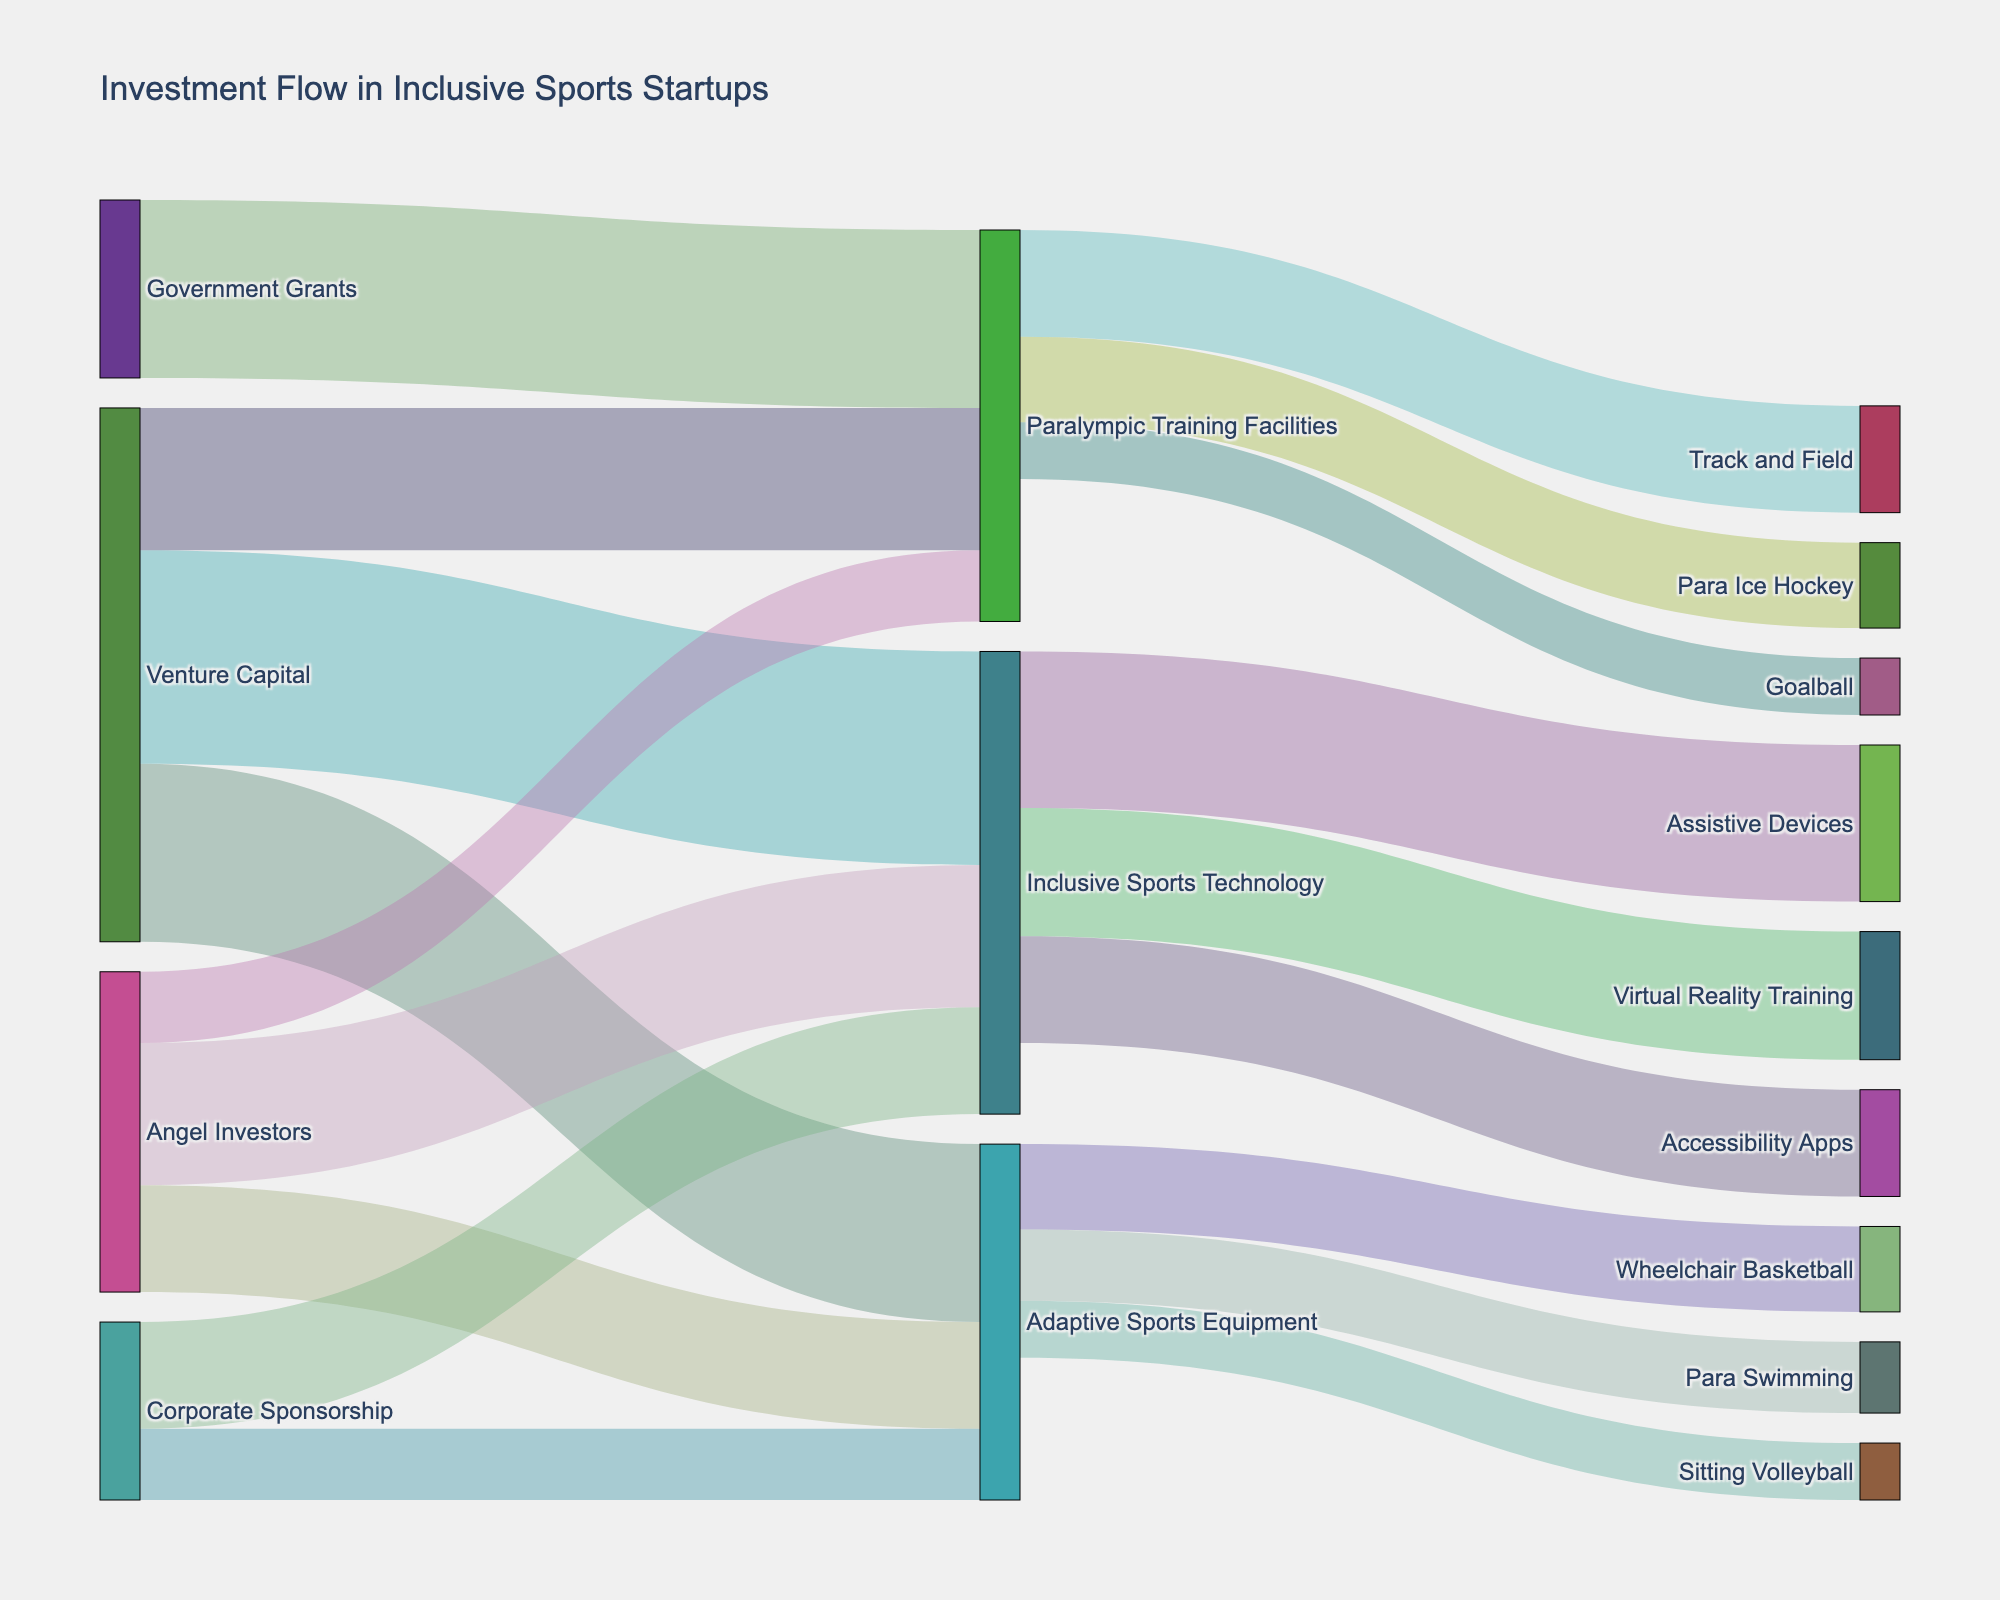What is the title of the Sankey Diagram? The title is located at the top of the diagram. Reading it can provide context about what the figure represents.
Answer: Investment Flow in Inclusive Sports Startups How many flow links connect to the 'Adaptive Sports Equipment' sector? Count the number of lines that both originate from and lead to 'Adaptive Sports Equipment'.
Answer: 3 Which funding source contributes the most to 'Inclusive Sports Technology'? Compare the values of flows from 'Angel Investors', 'Venture Capital', and 'Corporate Sponsorship' that direct towards 'Inclusive Sports Technology'. The highest value indicates the maximum contribution.
Answer: Venture Capital What is the total amount of investment flowing into 'Paralympic Training Facilities'? Sum the investment values from 'Angel Investors', 'Venture Capital', and 'Government Grants' directed towards 'Paralympic Training Facilities'.
Answer: 55 (10 + 20 + 25) Which sub-sector within 'Inclusive Sports Technology' receives the highest investment? Compare the investment values directed towards 'Virtual Reality Training', 'Assistive Devices', and 'Accessibility Apps'. The highest value indicates the maximum investment.
Answer: Assistive Devices How does the investment in 'Track and Field' compare to 'Para Ice Hockey'? Compare the investment amounts flowing into 'Track and Field' and 'Para Ice Hockey' within the 'Paralympic Training Facilities' category.
Answer: Track and Field receives more investment Which sub-sector within 'Adaptive Sports Equipment' gets the least amount of funding? Identify the smallest investment value among 'Wheelchair Basketball', 'Sitting Volleyball', and 'Para Swimming'.
Answer: Sitting Volleyball What is the total value of investments starting from 'Angel Investors'? Sum all of the values originating from 'Angel Investors' to 'Adaptive Sports Equipment', 'Inclusive Sports Technology', and 'Paralympic Training Facilities'.
Answer: 45 (15 + 20 + 10) How does the total investment from 'Venture Capital' compare to that from 'Corporate Sponsorship'? Sum the investments from 'Venture Capital' and compare it with the sum from 'Corporate Sponsorship'.
Answer: Venture Capital has more investments Which sector has the most diverse funding sources? Compare the number of unique funding sources for 'Adaptive Sports Equipment', 'Inclusive Sports Technology', and 'Paralympic Training Facilities'.
Answer: Paralympic Training Facilities 